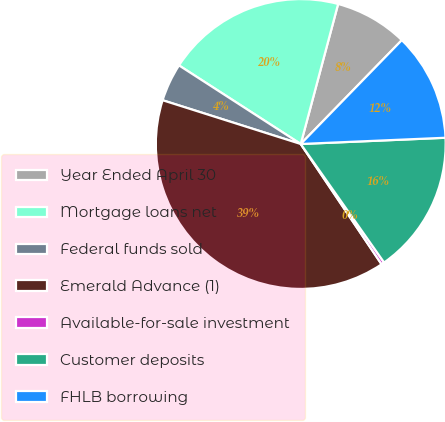<chart> <loc_0><loc_0><loc_500><loc_500><pie_chart><fcel>Year Ended April 30<fcel>Mortgage loans net<fcel>Federal funds sold<fcel>Emerald Advance (1)<fcel>Available-for-sale investment<fcel>Customer deposits<fcel>FHLB borrowing<nl><fcel>8.13%<fcel>20.03%<fcel>4.24%<fcel>39.3%<fcel>0.34%<fcel>15.93%<fcel>12.03%<nl></chart> 